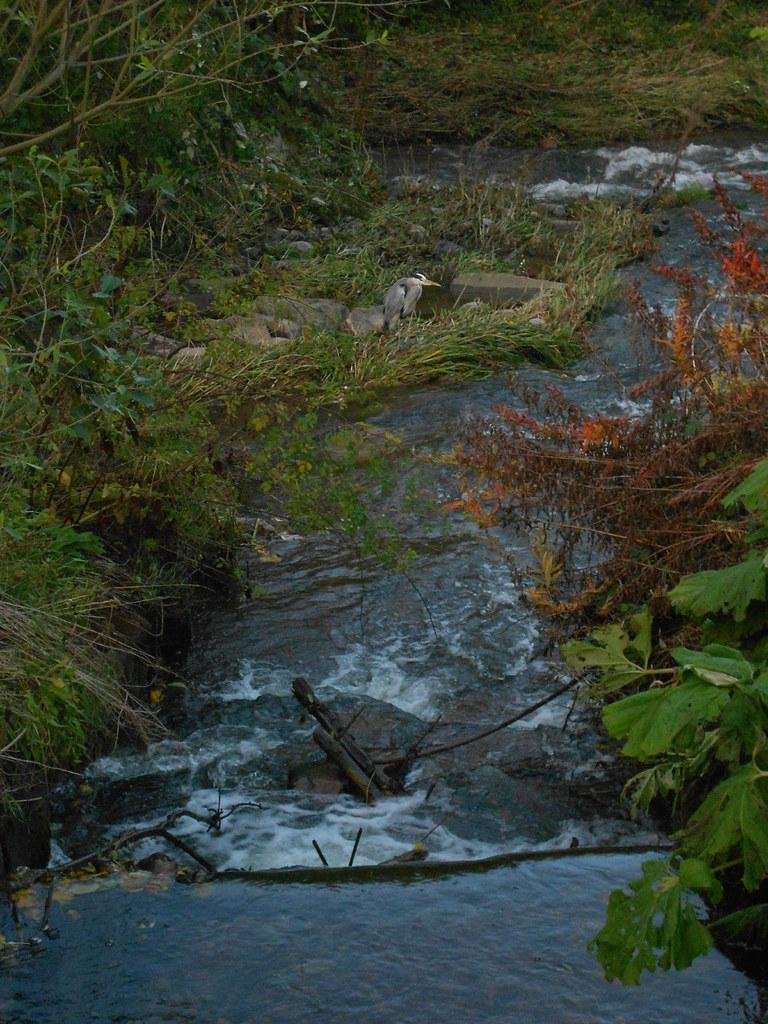What is the main feature in the center of the image? There is a canal in the center of the image. Are there any animals visible in the image? Yes, there is a bird in the image. What can be seen in the background of the image? There are plants and grass in the background of the image. How many chairs are visible in the image? There are no chairs present in the image. What type of chin can be seen on the bird in the image? There is no chin visible on the bird in the image, as birds do not have chins. 